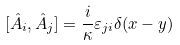<formula> <loc_0><loc_0><loc_500><loc_500>[ \hat { A } _ { i } , \hat { A } _ { j } ] = \frac { i } { \kappa } \varepsilon _ { j i } \delta ( x - y )</formula> 